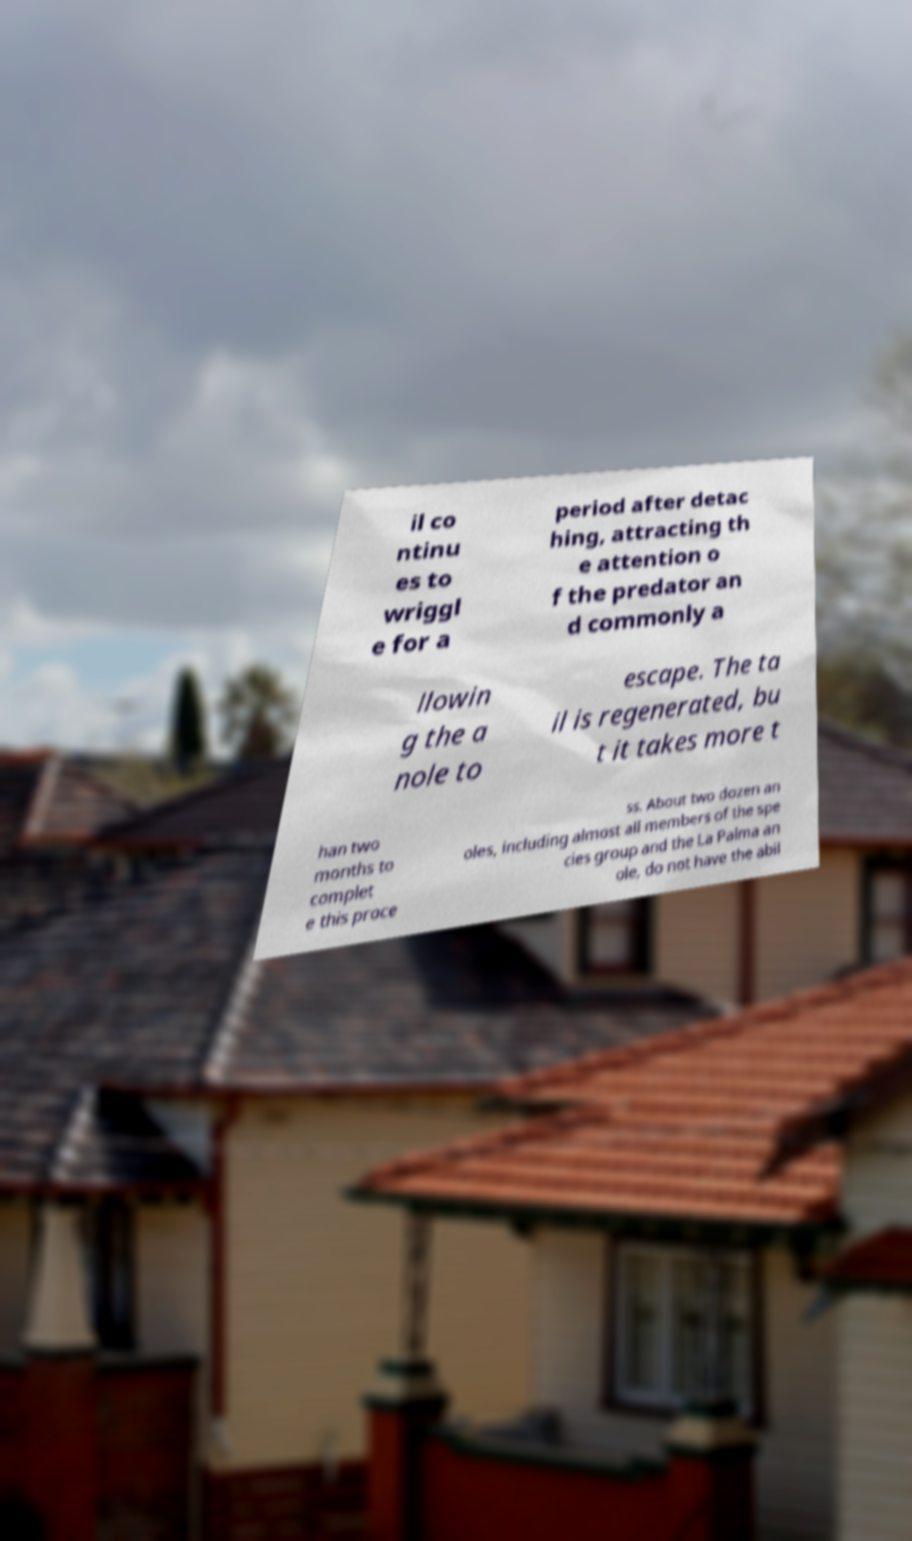Please identify and transcribe the text found in this image. il co ntinu es to wriggl e for a period after detac hing, attracting th e attention o f the predator an d commonly a llowin g the a nole to escape. The ta il is regenerated, bu t it takes more t han two months to complet e this proce ss. About two dozen an oles, including almost all members of the spe cies group and the La Palma an ole, do not have the abil 